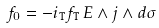Convert formula to latex. <formula><loc_0><loc_0><loc_500><loc_500>f _ { 0 } = - i _ { \tt T } f _ { \tt T } \, E \wedge j \wedge d \sigma \,</formula> 